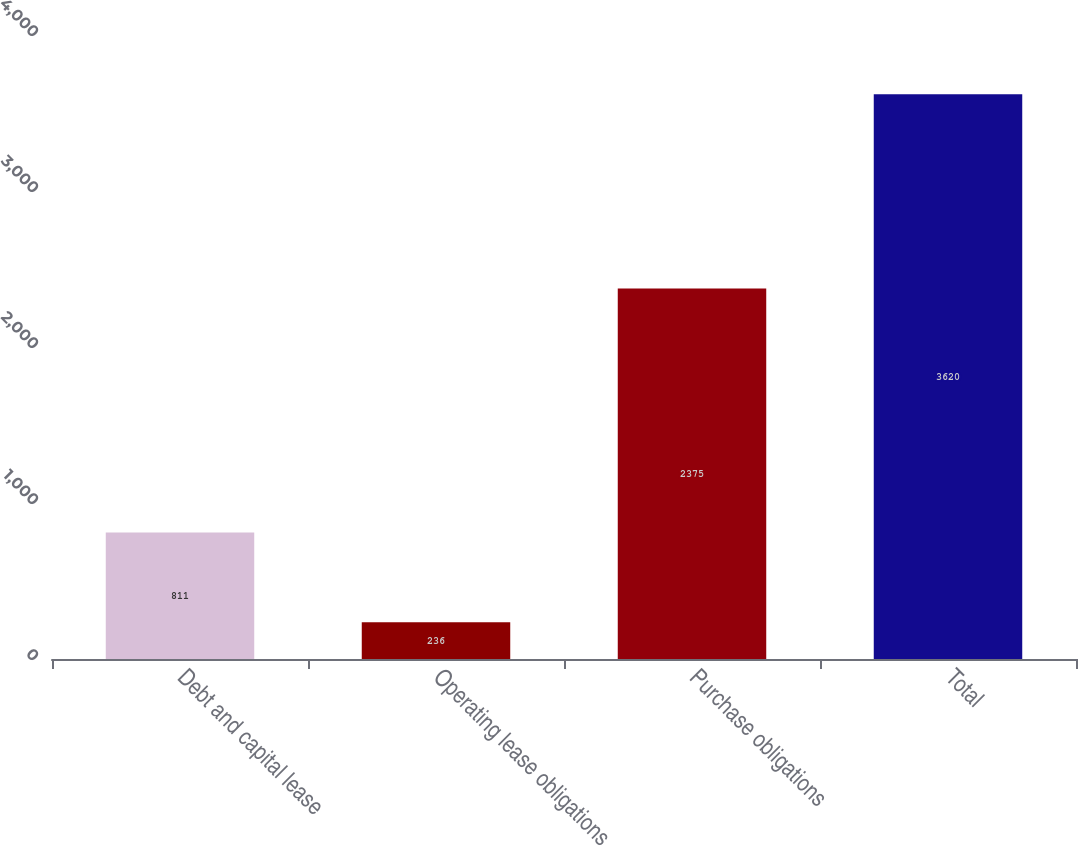Convert chart to OTSL. <chart><loc_0><loc_0><loc_500><loc_500><bar_chart><fcel>Debt and capital lease<fcel>Operating lease obligations<fcel>Purchase obligations<fcel>Total<nl><fcel>811<fcel>236<fcel>2375<fcel>3620<nl></chart> 